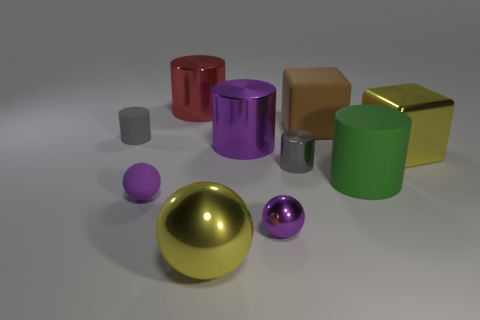Subtract all large shiny cylinders. How many cylinders are left? 3 Subtract all yellow cubes. How many cubes are left? 1 Subtract all balls. How many objects are left? 7 Subtract all matte cylinders. Subtract all tiny gray shiny things. How many objects are left? 7 Add 2 cylinders. How many cylinders are left? 7 Add 9 large red rubber cylinders. How many large red rubber cylinders exist? 9 Subtract 0 gray blocks. How many objects are left? 10 Subtract 2 cylinders. How many cylinders are left? 3 Subtract all red cubes. Subtract all gray balls. How many cubes are left? 2 Subtract all yellow spheres. How many gray cylinders are left? 2 